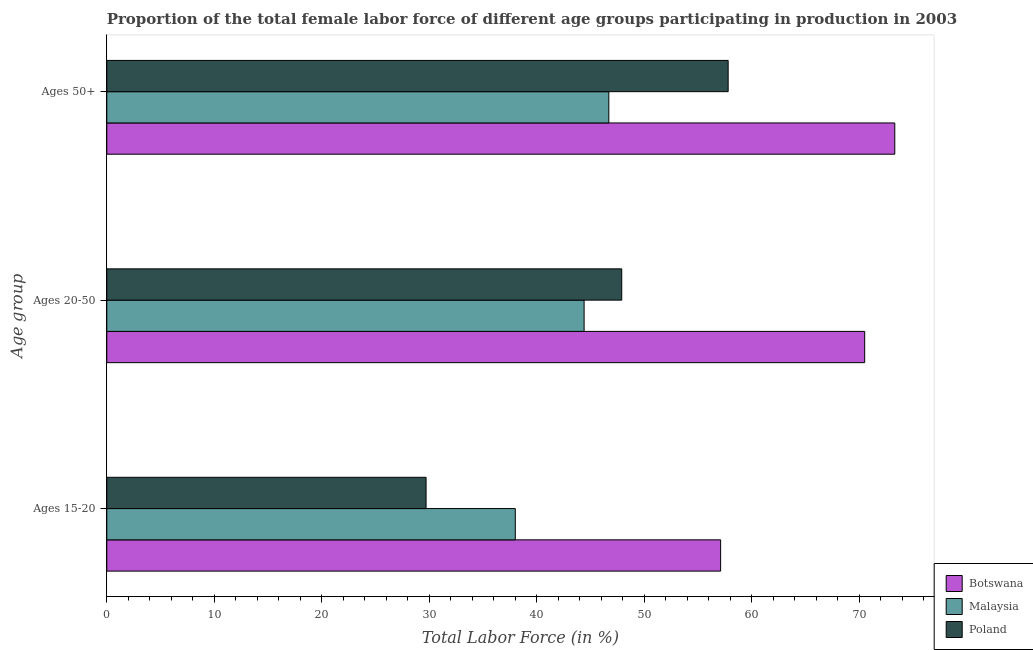How many groups of bars are there?
Offer a very short reply. 3. Are the number of bars per tick equal to the number of legend labels?
Make the answer very short. Yes. Are the number of bars on each tick of the Y-axis equal?
Make the answer very short. Yes. How many bars are there on the 2nd tick from the top?
Ensure brevity in your answer.  3. What is the label of the 1st group of bars from the top?
Offer a terse response. Ages 50+. What is the percentage of female labor force within the age group 20-50 in Malaysia?
Provide a succinct answer. 44.4. Across all countries, what is the maximum percentage of female labor force within the age group 20-50?
Provide a short and direct response. 70.5. Across all countries, what is the minimum percentage of female labor force within the age group 20-50?
Keep it short and to the point. 44.4. In which country was the percentage of female labor force within the age group 15-20 maximum?
Offer a terse response. Botswana. In which country was the percentage of female labor force within the age group 15-20 minimum?
Your response must be concise. Poland. What is the total percentage of female labor force above age 50 in the graph?
Your response must be concise. 177.8. What is the difference between the percentage of female labor force within the age group 20-50 in Botswana and that in Malaysia?
Make the answer very short. 26.1. What is the difference between the percentage of female labor force within the age group 15-20 in Botswana and the percentage of female labor force above age 50 in Poland?
Your answer should be very brief. -0.7. What is the average percentage of female labor force above age 50 per country?
Your response must be concise. 59.27. What is the difference between the percentage of female labor force above age 50 and percentage of female labor force within the age group 15-20 in Malaysia?
Your answer should be compact. 8.7. What is the ratio of the percentage of female labor force within the age group 15-20 in Malaysia to that in Poland?
Provide a succinct answer. 1.28. Is the difference between the percentage of female labor force within the age group 15-20 in Botswana and Malaysia greater than the difference between the percentage of female labor force within the age group 20-50 in Botswana and Malaysia?
Your answer should be very brief. No. What is the difference between the highest and the second highest percentage of female labor force within the age group 20-50?
Keep it short and to the point. 22.6. What is the difference between the highest and the lowest percentage of female labor force within the age group 20-50?
Offer a terse response. 26.1. In how many countries, is the percentage of female labor force within the age group 20-50 greater than the average percentage of female labor force within the age group 20-50 taken over all countries?
Ensure brevity in your answer.  1. Is the sum of the percentage of female labor force within the age group 20-50 in Botswana and Malaysia greater than the maximum percentage of female labor force within the age group 15-20 across all countries?
Keep it short and to the point. Yes. What does the 2nd bar from the bottom in Ages 15-20 represents?
Offer a terse response. Malaysia. Is it the case that in every country, the sum of the percentage of female labor force within the age group 15-20 and percentage of female labor force within the age group 20-50 is greater than the percentage of female labor force above age 50?
Make the answer very short. Yes. Are all the bars in the graph horizontal?
Your response must be concise. Yes. How are the legend labels stacked?
Your answer should be compact. Vertical. What is the title of the graph?
Provide a short and direct response. Proportion of the total female labor force of different age groups participating in production in 2003. Does "Bermuda" appear as one of the legend labels in the graph?
Provide a short and direct response. No. What is the label or title of the X-axis?
Offer a very short reply. Total Labor Force (in %). What is the label or title of the Y-axis?
Your answer should be very brief. Age group. What is the Total Labor Force (in %) of Botswana in Ages 15-20?
Provide a short and direct response. 57.1. What is the Total Labor Force (in %) of Poland in Ages 15-20?
Provide a succinct answer. 29.7. What is the Total Labor Force (in %) of Botswana in Ages 20-50?
Ensure brevity in your answer.  70.5. What is the Total Labor Force (in %) of Malaysia in Ages 20-50?
Provide a succinct answer. 44.4. What is the Total Labor Force (in %) of Poland in Ages 20-50?
Provide a short and direct response. 47.9. What is the Total Labor Force (in %) in Botswana in Ages 50+?
Ensure brevity in your answer.  73.3. What is the Total Labor Force (in %) of Malaysia in Ages 50+?
Offer a very short reply. 46.7. What is the Total Labor Force (in %) in Poland in Ages 50+?
Provide a short and direct response. 57.8. Across all Age group, what is the maximum Total Labor Force (in %) of Botswana?
Offer a terse response. 73.3. Across all Age group, what is the maximum Total Labor Force (in %) in Malaysia?
Ensure brevity in your answer.  46.7. Across all Age group, what is the maximum Total Labor Force (in %) of Poland?
Your response must be concise. 57.8. Across all Age group, what is the minimum Total Labor Force (in %) of Botswana?
Ensure brevity in your answer.  57.1. Across all Age group, what is the minimum Total Labor Force (in %) in Malaysia?
Keep it short and to the point. 38. Across all Age group, what is the minimum Total Labor Force (in %) of Poland?
Keep it short and to the point. 29.7. What is the total Total Labor Force (in %) in Botswana in the graph?
Make the answer very short. 200.9. What is the total Total Labor Force (in %) in Malaysia in the graph?
Your answer should be very brief. 129.1. What is the total Total Labor Force (in %) in Poland in the graph?
Give a very brief answer. 135.4. What is the difference between the Total Labor Force (in %) in Botswana in Ages 15-20 and that in Ages 20-50?
Your answer should be compact. -13.4. What is the difference between the Total Labor Force (in %) in Poland in Ages 15-20 and that in Ages 20-50?
Provide a succinct answer. -18.2. What is the difference between the Total Labor Force (in %) in Botswana in Ages 15-20 and that in Ages 50+?
Give a very brief answer. -16.2. What is the difference between the Total Labor Force (in %) of Malaysia in Ages 15-20 and that in Ages 50+?
Offer a very short reply. -8.7. What is the difference between the Total Labor Force (in %) in Poland in Ages 15-20 and that in Ages 50+?
Keep it short and to the point. -28.1. What is the difference between the Total Labor Force (in %) in Botswana in Ages 15-20 and the Total Labor Force (in %) in Poland in Ages 20-50?
Give a very brief answer. 9.2. What is the difference between the Total Labor Force (in %) of Malaysia in Ages 15-20 and the Total Labor Force (in %) of Poland in Ages 50+?
Provide a succinct answer. -19.8. What is the difference between the Total Labor Force (in %) in Botswana in Ages 20-50 and the Total Labor Force (in %) in Malaysia in Ages 50+?
Ensure brevity in your answer.  23.8. What is the difference between the Total Labor Force (in %) in Botswana in Ages 20-50 and the Total Labor Force (in %) in Poland in Ages 50+?
Make the answer very short. 12.7. What is the average Total Labor Force (in %) of Botswana per Age group?
Your answer should be very brief. 66.97. What is the average Total Labor Force (in %) of Malaysia per Age group?
Keep it short and to the point. 43.03. What is the average Total Labor Force (in %) in Poland per Age group?
Offer a very short reply. 45.13. What is the difference between the Total Labor Force (in %) of Botswana and Total Labor Force (in %) of Poland in Ages 15-20?
Keep it short and to the point. 27.4. What is the difference between the Total Labor Force (in %) in Malaysia and Total Labor Force (in %) in Poland in Ages 15-20?
Offer a terse response. 8.3. What is the difference between the Total Labor Force (in %) of Botswana and Total Labor Force (in %) of Malaysia in Ages 20-50?
Give a very brief answer. 26.1. What is the difference between the Total Labor Force (in %) in Botswana and Total Labor Force (in %) in Poland in Ages 20-50?
Provide a succinct answer. 22.6. What is the difference between the Total Labor Force (in %) of Malaysia and Total Labor Force (in %) of Poland in Ages 20-50?
Provide a short and direct response. -3.5. What is the difference between the Total Labor Force (in %) of Botswana and Total Labor Force (in %) of Malaysia in Ages 50+?
Ensure brevity in your answer.  26.6. What is the ratio of the Total Labor Force (in %) in Botswana in Ages 15-20 to that in Ages 20-50?
Offer a terse response. 0.81. What is the ratio of the Total Labor Force (in %) of Malaysia in Ages 15-20 to that in Ages 20-50?
Keep it short and to the point. 0.86. What is the ratio of the Total Labor Force (in %) in Poland in Ages 15-20 to that in Ages 20-50?
Offer a very short reply. 0.62. What is the ratio of the Total Labor Force (in %) in Botswana in Ages 15-20 to that in Ages 50+?
Offer a very short reply. 0.78. What is the ratio of the Total Labor Force (in %) of Malaysia in Ages 15-20 to that in Ages 50+?
Your response must be concise. 0.81. What is the ratio of the Total Labor Force (in %) in Poland in Ages 15-20 to that in Ages 50+?
Your answer should be very brief. 0.51. What is the ratio of the Total Labor Force (in %) of Botswana in Ages 20-50 to that in Ages 50+?
Your response must be concise. 0.96. What is the ratio of the Total Labor Force (in %) in Malaysia in Ages 20-50 to that in Ages 50+?
Offer a terse response. 0.95. What is the ratio of the Total Labor Force (in %) of Poland in Ages 20-50 to that in Ages 50+?
Your answer should be very brief. 0.83. What is the difference between the highest and the lowest Total Labor Force (in %) of Botswana?
Make the answer very short. 16.2. What is the difference between the highest and the lowest Total Labor Force (in %) of Malaysia?
Offer a terse response. 8.7. What is the difference between the highest and the lowest Total Labor Force (in %) in Poland?
Give a very brief answer. 28.1. 